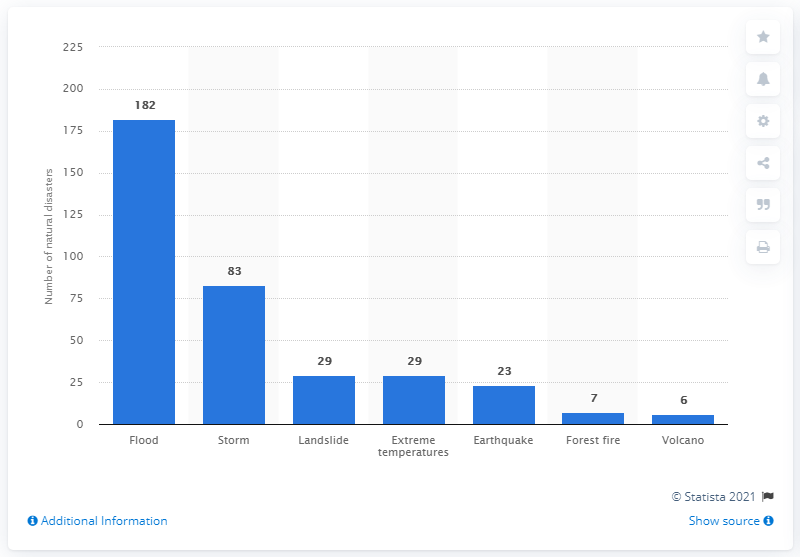Indicate a few pertinent items in this graphic. There were 182 floods in the year 2010. 